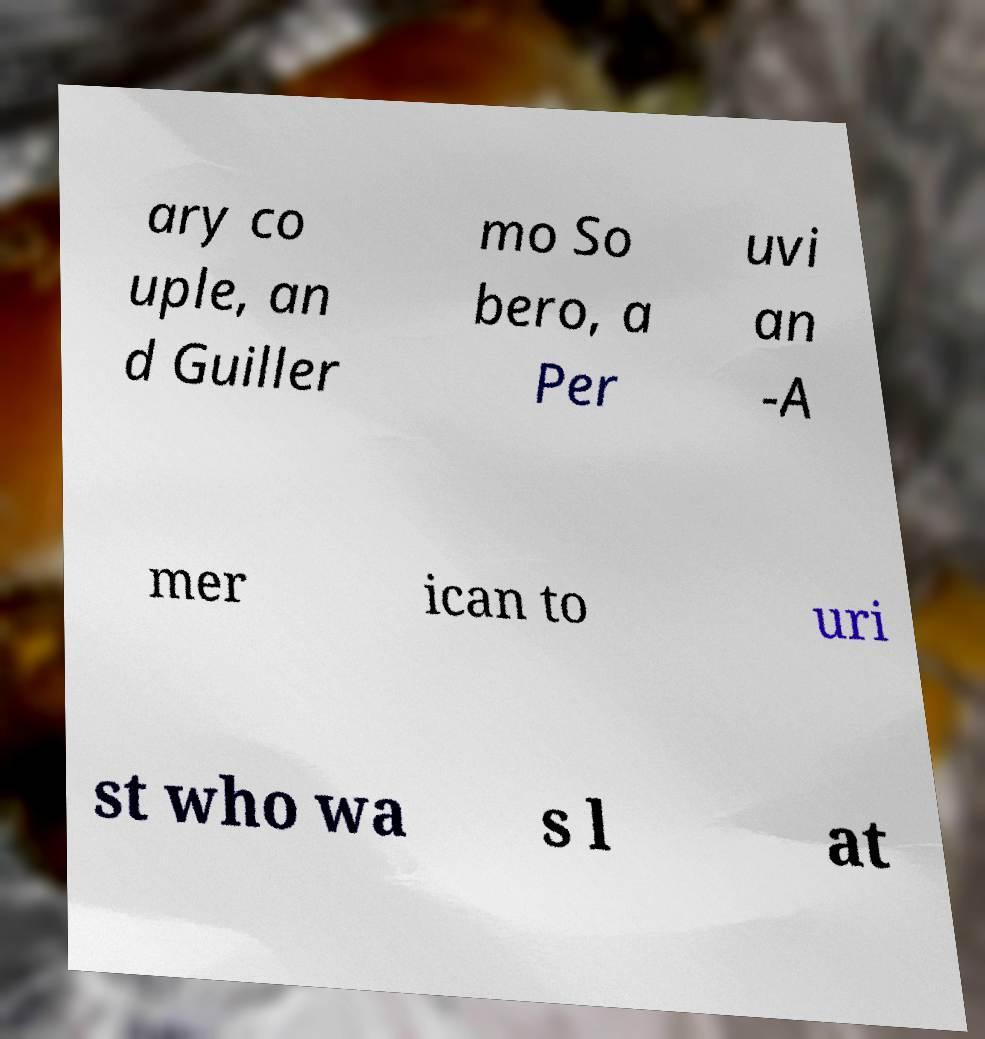Could you assist in decoding the text presented in this image and type it out clearly? ary co uple, an d Guiller mo So bero, a Per uvi an -A mer ican to uri st who wa s l at 